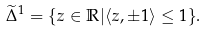Convert formula to latex. <formula><loc_0><loc_0><loc_500><loc_500>\widetilde { \Delta } ^ { 1 } = \{ z \in \mathbb { R } | & \langle z , \pm 1 \rangle \leq 1 \} .</formula> 